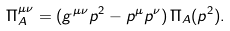Convert formula to latex. <formula><loc_0><loc_0><loc_500><loc_500>\Pi ^ { \mu \nu } _ { A } = ( g ^ { \mu \nu } p ^ { 2 } - p ^ { \mu } p ^ { \nu } ) \, \Pi _ { A } ( p ^ { 2 } ) .</formula> 